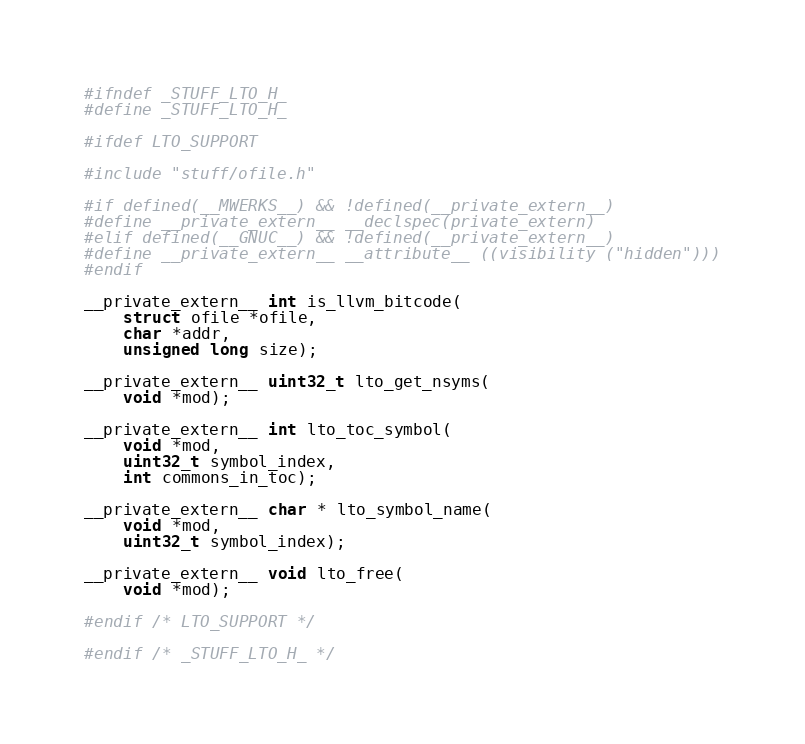<code> <loc_0><loc_0><loc_500><loc_500><_C_>#ifndef _STUFF_LTO_H_
#define _STUFF_LTO_H_

#ifdef LTO_SUPPORT

#include "stuff/ofile.h"

#if defined(__MWERKS__) && !defined(__private_extern__)
#define __private_extern__ __declspec(private_extern)
#elif defined(__GNUC__) && !defined(__private_extern__)
#define __private_extern__ __attribute__ ((visibility ("hidden")))
#endif

__private_extern__ int is_llvm_bitcode(
    struct ofile *ofile,
    char *addr,
    unsigned long size);

__private_extern__ uint32_t lto_get_nsyms(
    void *mod);

__private_extern__ int lto_toc_symbol(
    void *mod,
    uint32_t symbol_index,
    int commons_in_toc);

__private_extern__ char * lto_symbol_name(
    void *mod,
    uint32_t symbol_index);

__private_extern__ void lto_free(
    void *mod);

#endif /* LTO_SUPPORT */

#endif /* _STUFF_LTO_H_ */
</code> 